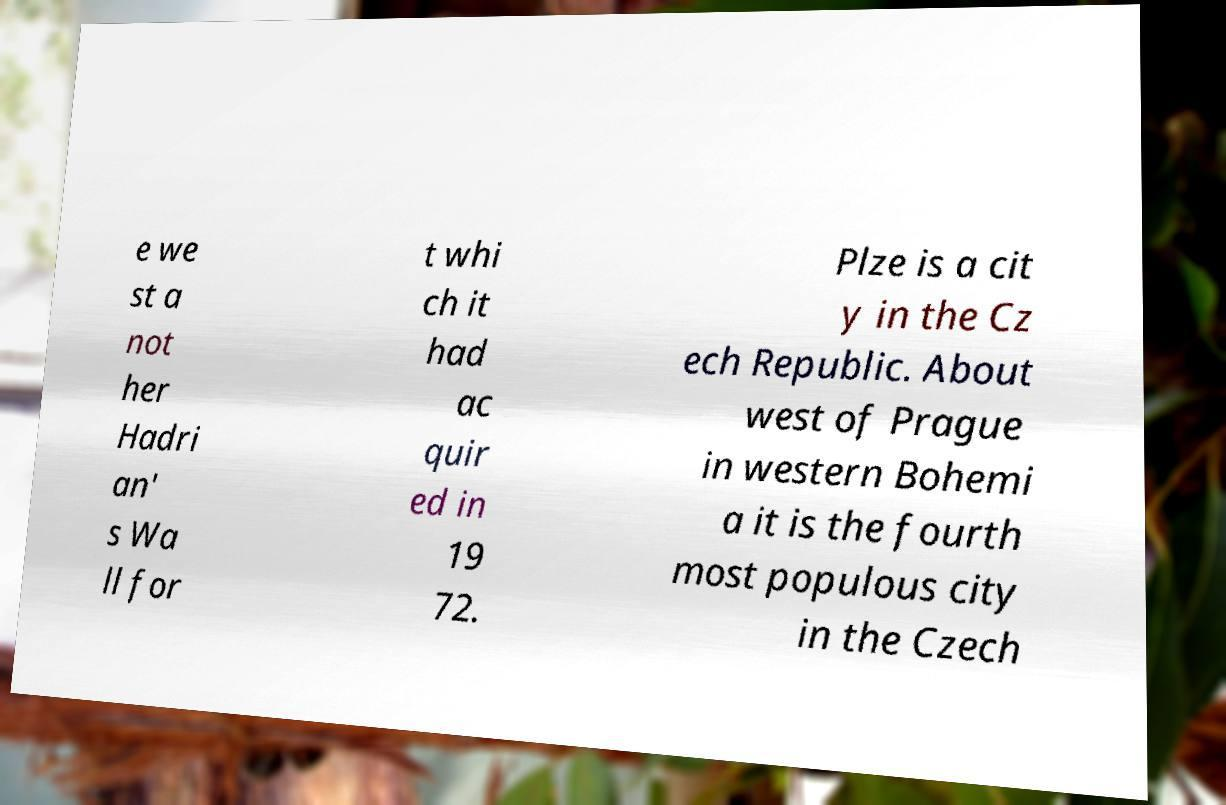What messages or text are displayed in this image? I need them in a readable, typed format. e we st a not her Hadri an' s Wa ll for t whi ch it had ac quir ed in 19 72. Plze is a cit y in the Cz ech Republic. About west of Prague in western Bohemi a it is the fourth most populous city in the Czech 